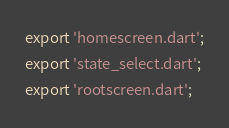Convert code to text. <code><loc_0><loc_0><loc_500><loc_500><_Dart_>export 'homescreen.dart';
export 'state_select.dart';
export 'rootscreen.dart';</code> 